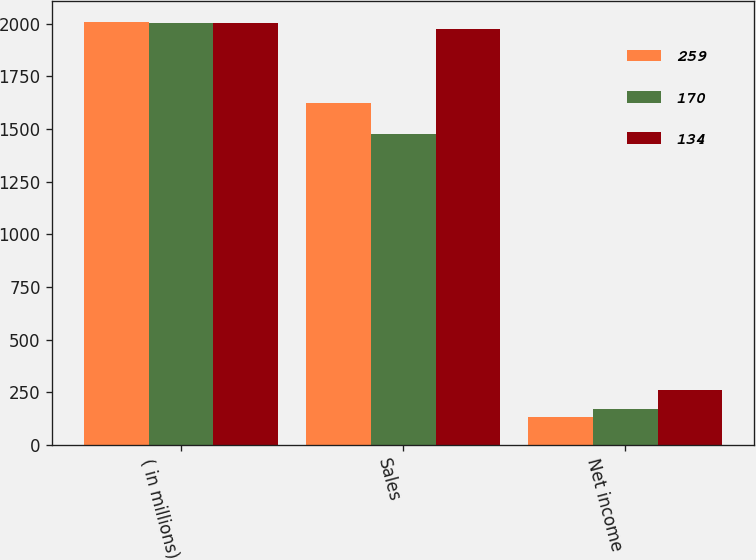Convert chart to OTSL. <chart><loc_0><loc_0><loc_500><loc_500><stacked_bar_chart><ecel><fcel>( in millions)<fcel>Sales<fcel>Net income<nl><fcel>259<fcel>2007<fcel>1622<fcel>134<nl><fcel>170<fcel>2006<fcel>1479<fcel>170<nl><fcel>134<fcel>2005<fcel>1975<fcel>259<nl></chart> 